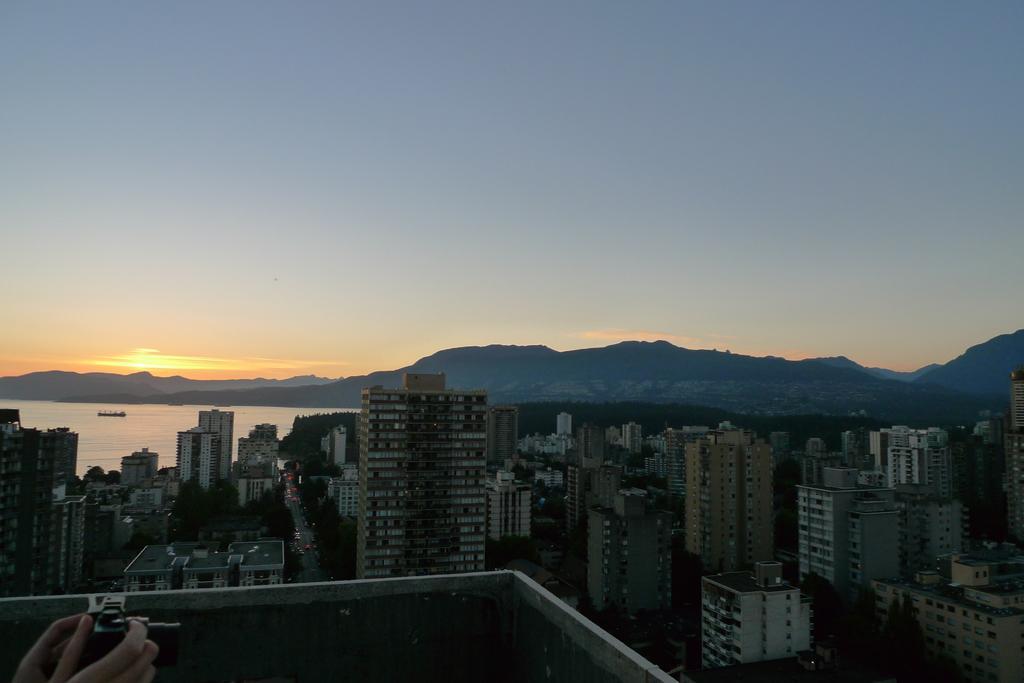Please provide a concise description of this image. This is an aerial view of an image where we can see a person's hand holding the camera is on the left side of the image. Here I can see tower buildings, a boat floating on the water, I can see hills, sunset and the sky in the background. 